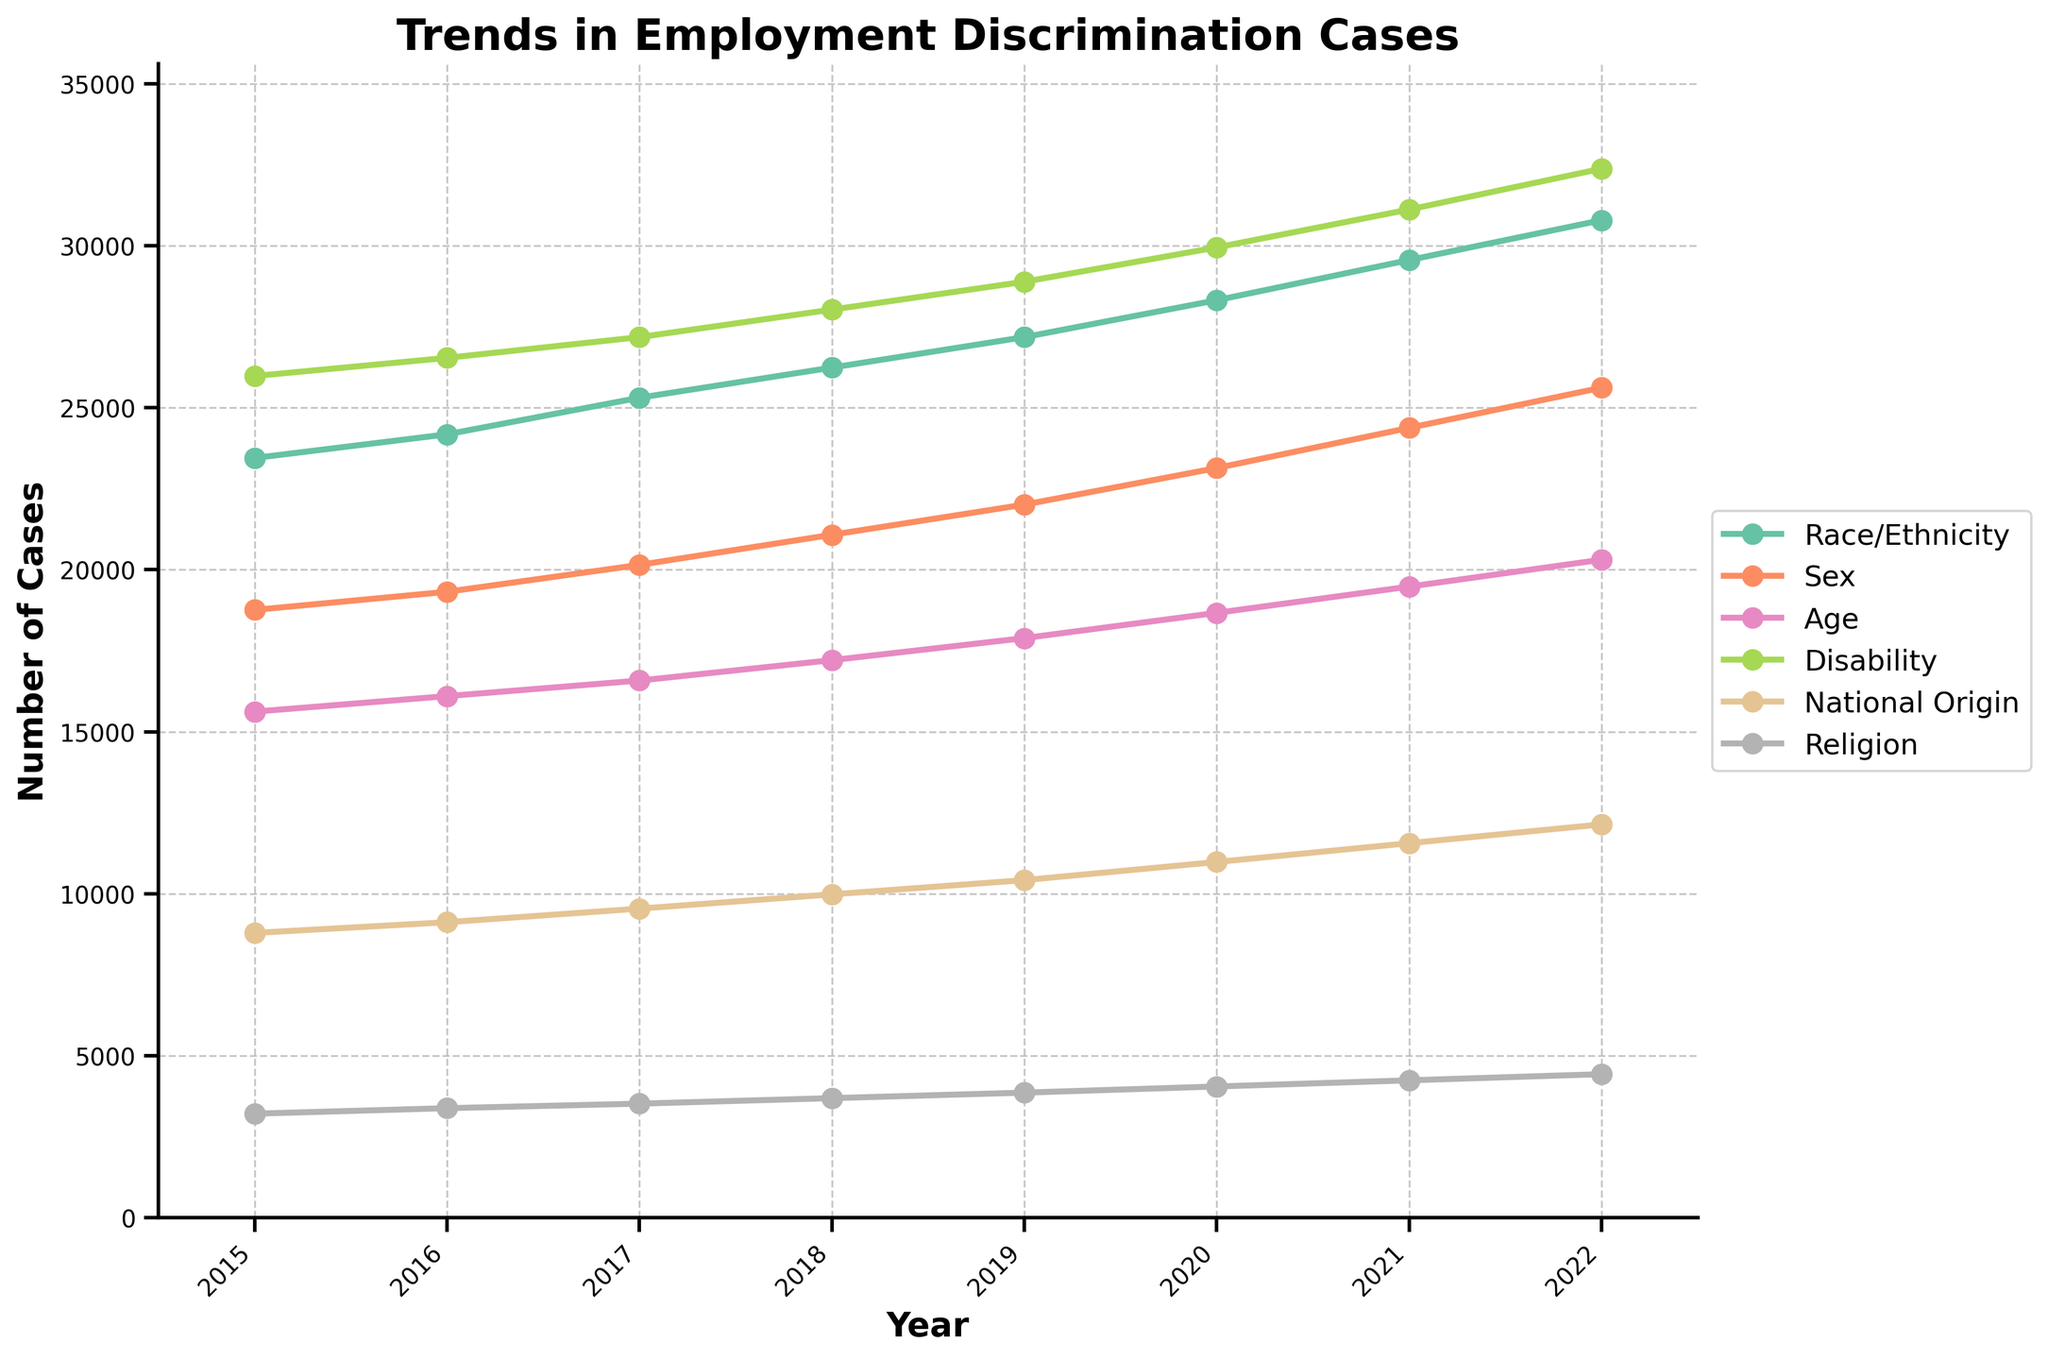what is the category with the highest number of cases filed annually in 2020? Locate the year 2020 on the x-axis and check the corresponding y-values for each category. The category with the highest y-value is Disability with 29,950 cases.
Answer: Disability Which category showed the largest increase in the number of cases from 2015 to 2022? Calculate the difference in the number of cases for each category between 2015 and 2022. Compare these differences to find which one is the largest. Disability increased the most from 25,980 to 32,380, showing an increase of 6,400 cases.
Answer: Disability Which two categories had the closest number of cases filed in 2017? For the year 2017, compare the y-values of all categories and identify the two categories that are numerically closest. Age (16,580) and National Origin (15,490) are the closest, differing by only 90 cases.
Answer: Age and National Origin What is the average number of cases filed for the category of Race/Ethnicity over the years shown? Sum the number of cases filed for Race/Ethnicity for each year and divide by the number of years. (23450+24180+25310+26240+27180+28320+29560+30790)/8 = 26,416.25
Answer: 26,416.25 What trend can you observe for the category of Religion? Locate the y-values associated with Religion for each year and observe the trend. Religion cases show a consistent increase each year from 3,210 in 2015 to 4,430 in 2022.
Answer: Consistent increase In which year did the category of Sex cases surpass 20,000? Trace the y-values for the category of Sex across the years and identify when it first surpasses 20,000 cases. In 2017, Sex cases reached 20,150.
Answer: 2017 What is the sum of cases filed for Age and National Origin in 2018? Add the y-values for Age and National Origin for the year 2018. Age: 17,210 + National Origin: 9,980 = 27,190
Answer: 27,190 Which category showed the least increase in number of cases from 2015 to 2022? Calculate the difference in the number of cases for each category between 2015 and 2022. Religion showed the smallest increase from 3,210 to 4,430, an increase of 1,220 cases.
Answer: Religion At what rate did the number of cases for Race/Ethnicity increase each year on average? Calculate the annual increase by taking the difference of cases each year for Race/Ethnicity and averaging these differences. The average rate is (24,180-23,450 + 25,310-24,180 + 26,240-25,310 + 27,180-26,240 + 28,320-27,180 + 29,560-28,320 + 30,790-29,560)/7 = 1,190.
Answer: 1,190 